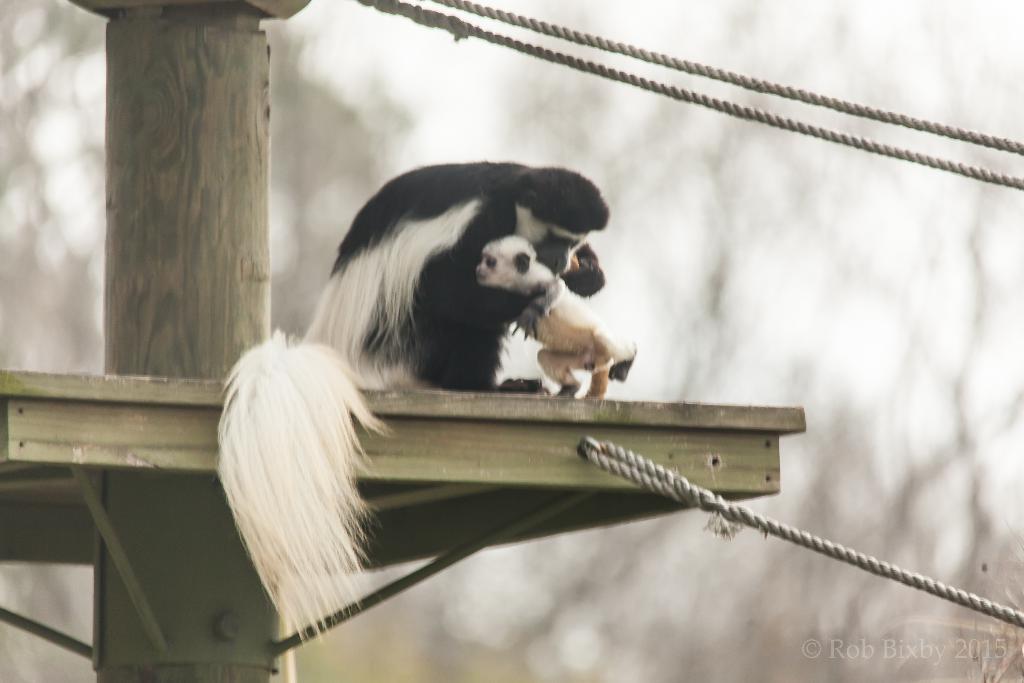Please provide a concise description of this image. In this image in the center there are animals, and in the center there is a wooden board, wooden pole and some ropes. And in the background there are trees. 